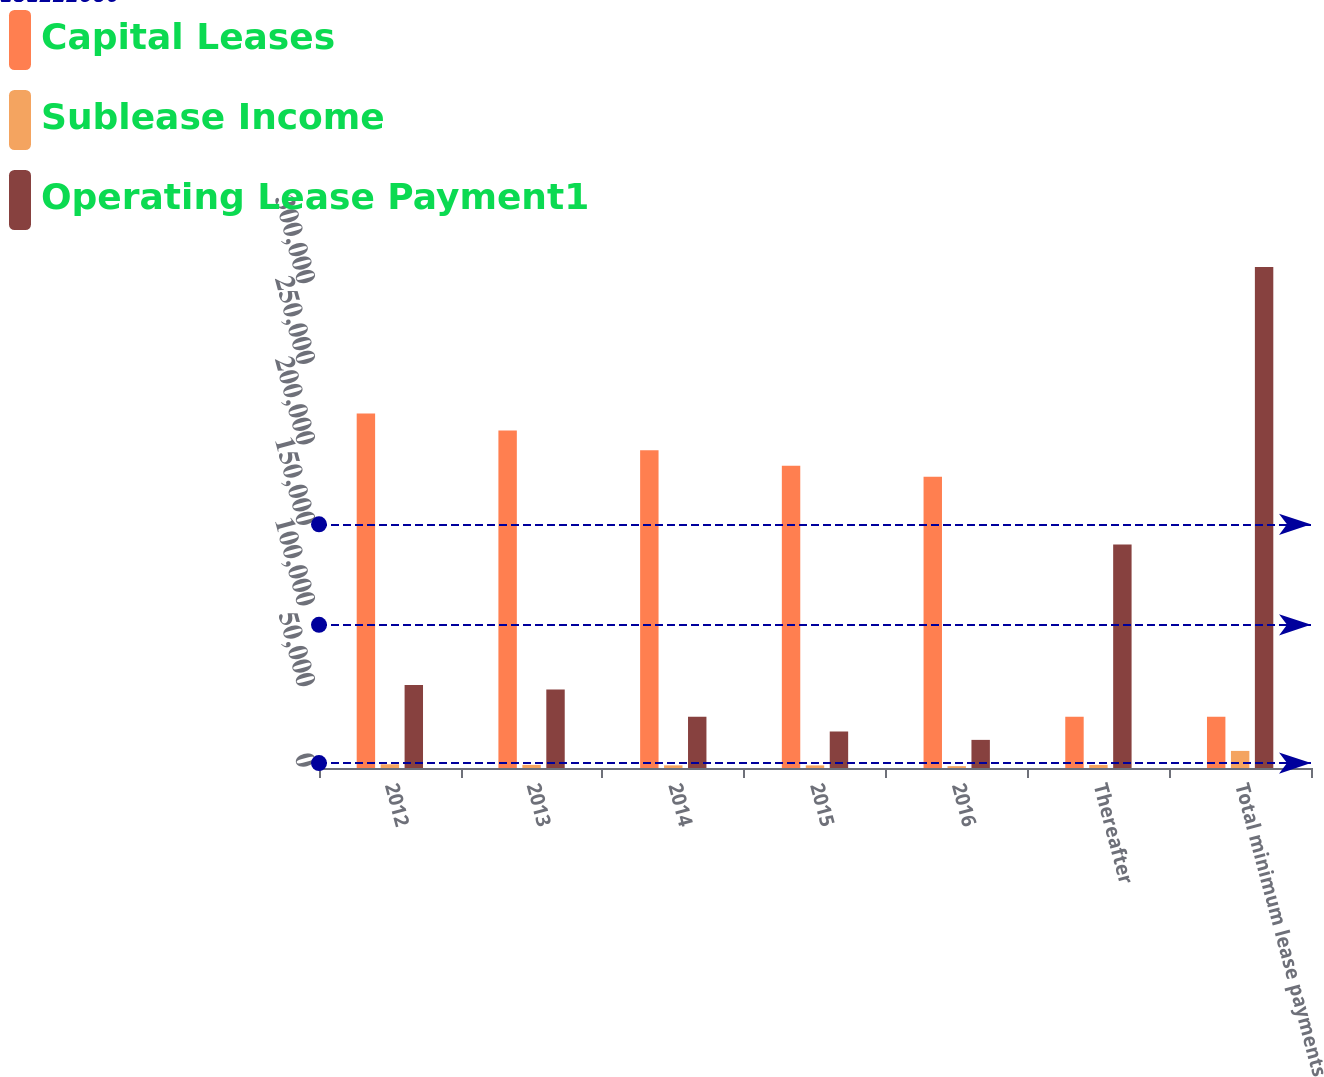Convert chart to OTSL. <chart><loc_0><loc_0><loc_500><loc_500><stacked_bar_chart><ecel><fcel>2012<fcel>2013<fcel>2014<fcel>2015<fcel>2016<fcel>Thereafter<fcel>Total minimum lease payments<nl><fcel>Capital Leases<fcel>219951<fcel>209417<fcel>197258<fcel>187507<fcel>180753<fcel>31837<fcel>31837<nl><fcel>Sublease Income<fcel>2317<fcel>1932<fcel>1648<fcel>1629<fcel>1145<fcel>1934<fcel>10605<nl><fcel>Operating Lease Payment1<fcel>51490<fcel>48787<fcel>31837<fcel>22655<fcel>17450<fcel>138661<fcel>310880<nl></chart> 